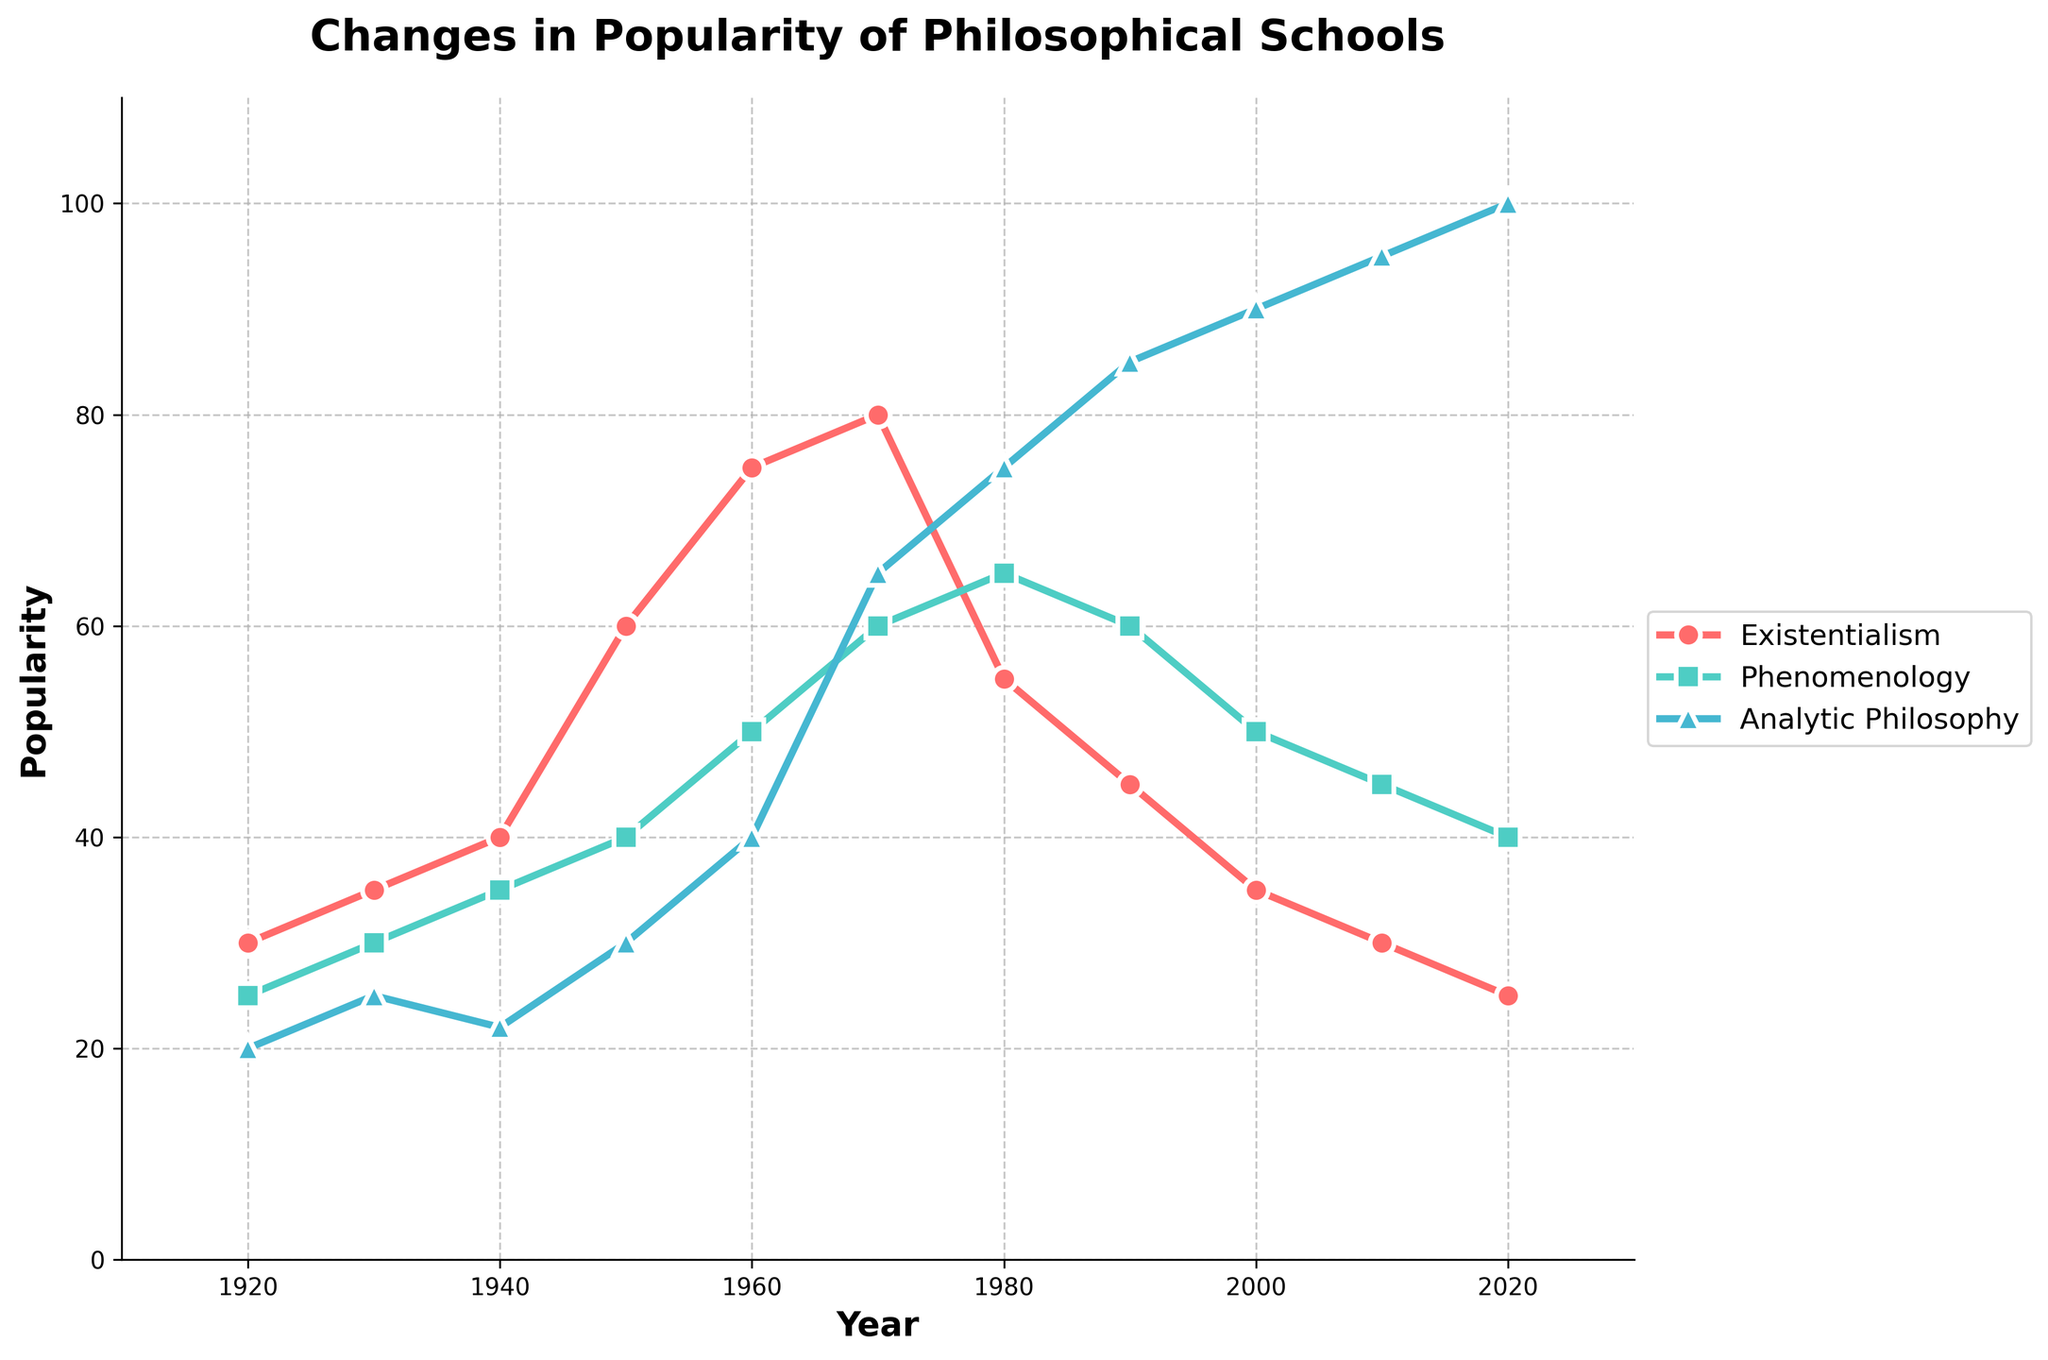What is the title of the figure? The title is usually the first visible text at the top of the figure, distinguishing it from other labels or legends.
Answer: Changes in Popularity of Philosophical Schools What is the most recent year shown on the x-axis? The x-axis typically represents time in a time series plot and is labeled with years. The farthest point on the right indicates the most recent year.
Answer: 2020 Which philosophical school had the highest popularity in 1980? By identifying the year 1980 on the x-axis and moving vertically to check the y-values, the highest point corresponds to the most popular school.
Answer: Analytic Philosophy During which decade does Existentialism achieve its peak popularity? Locate the highest point on the Existentialism line and note the corresponding year. The decade containing this year is the answer.
Answer: 1970s In what year does Phenomenology first reach a popularity of 60? Trace the Phenomenology line to find where it first intersects the y-axis value of 60, then note the corresponding x-axis year.
Answer: 1970 On average, how did the popularity of Analytic Philosophy change per decade from 1920 to 2020? Calculate the difference between the 2020 and 1920 values for Analytic Philosophy, then divide by the number of decades (10). Difference = 100 - 20 = 80; 80 / 10 = 8.
Answer: Increased by 8 per decade Compare the popularity of Existentialism and Phenomenology in 1960. Which was more popular, and by how much? Identify both y-values for 1960, then subtract the Phenomenology popularity from the Existentialism popularity.
Answer: Existentialism was more popular by 25 What trend can be observed in the Analytic Philosophy popularity from 2000 to 2020? Analyze the change in y-values for Analytic Philosophy between 2000 and 2020. Notice whether it increases, decreases, or remains constant.
Answer: Increased Which philosophical school shows a steady decline in popularity after reaching its peak? Examine each line for the point where it peaks and check if it shows a consistent drop afterward. Look for slopes trending downward.
Answer: Existentialism How many data points are plotted for each philosophical school of thought? Count the number of points in the time series lines for any of the schools; they all have the same count as the intervals are consistent.
Answer: 11 